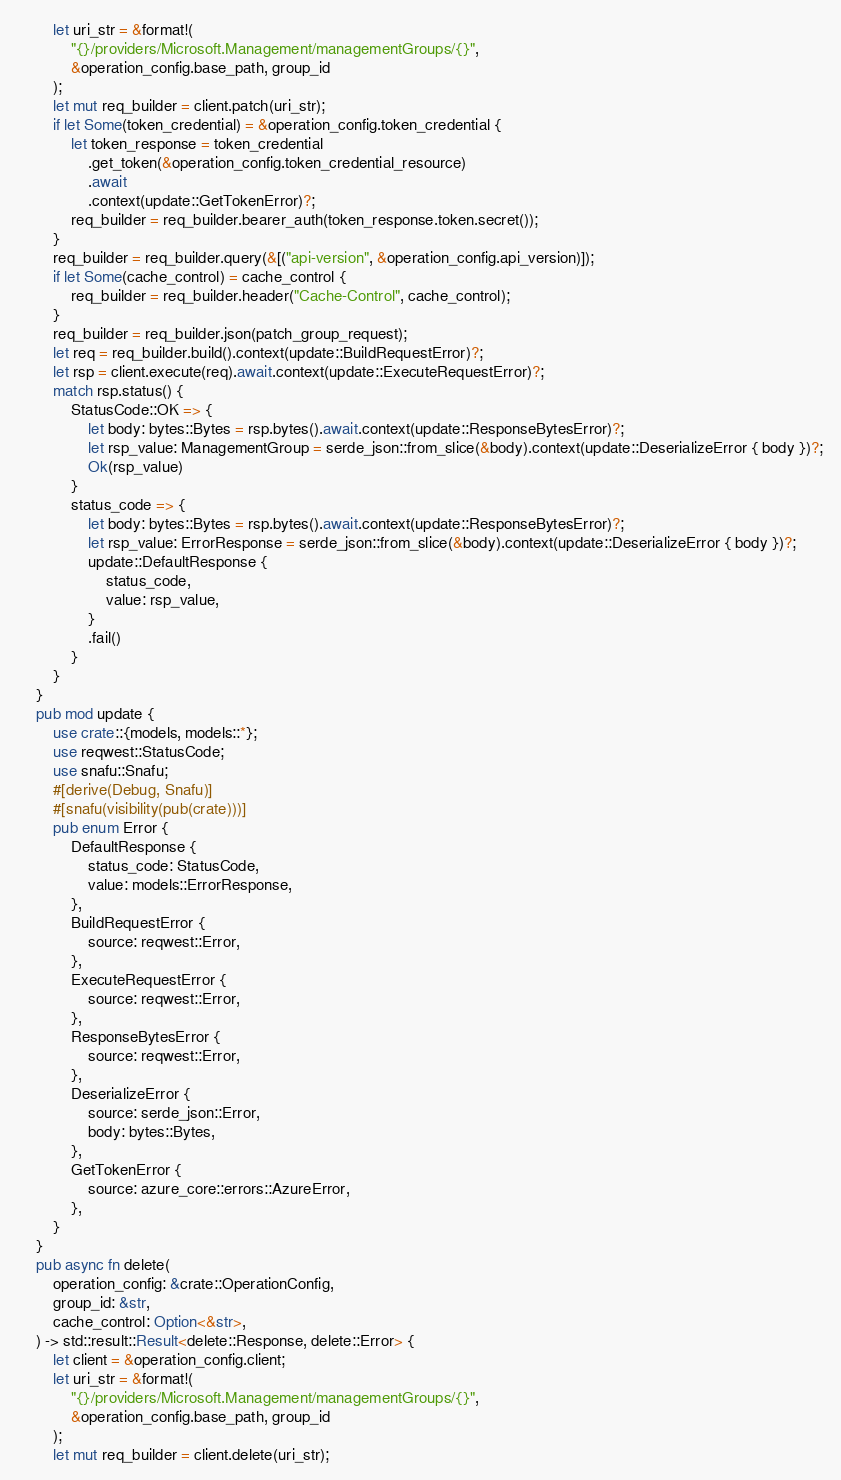Convert code to text. <code><loc_0><loc_0><loc_500><loc_500><_Rust_>        let uri_str = &format!(
            "{}/providers/Microsoft.Management/managementGroups/{}",
            &operation_config.base_path, group_id
        );
        let mut req_builder = client.patch(uri_str);
        if let Some(token_credential) = &operation_config.token_credential {
            let token_response = token_credential
                .get_token(&operation_config.token_credential_resource)
                .await
                .context(update::GetTokenError)?;
            req_builder = req_builder.bearer_auth(token_response.token.secret());
        }
        req_builder = req_builder.query(&[("api-version", &operation_config.api_version)]);
        if let Some(cache_control) = cache_control {
            req_builder = req_builder.header("Cache-Control", cache_control);
        }
        req_builder = req_builder.json(patch_group_request);
        let req = req_builder.build().context(update::BuildRequestError)?;
        let rsp = client.execute(req).await.context(update::ExecuteRequestError)?;
        match rsp.status() {
            StatusCode::OK => {
                let body: bytes::Bytes = rsp.bytes().await.context(update::ResponseBytesError)?;
                let rsp_value: ManagementGroup = serde_json::from_slice(&body).context(update::DeserializeError { body })?;
                Ok(rsp_value)
            }
            status_code => {
                let body: bytes::Bytes = rsp.bytes().await.context(update::ResponseBytesError)?;
                let rsp_value: ErrorResponse = serde_json::from_slice(&body).context(update::DeserializeError { body })?;
                update::DefaultResponse {
                    status_code,
                    value: rsp_value,
                }
                .fail()
            }
        }
    }
    pub mod update {
        use crate::{models, models::*};
        use reqwest::StatusCode;
        use snafu::Snafu;
        #[derive(Debug, Snafu)]
        #[snafu(visibility(pub(crate)))]
        pub enum Error {
            DefaultResponse {
                status_code: StatusCode,
                value: models::ErrorResponse,
            },
            BuildRequestError {
                source: reqwest::Error,
            },
            ExecuteRequestError {
                source: reqwest::Error,
            },
            ResponseBytesError {
                source: reqwest::Error,
            },
            DeserializeError {
                source: serde_json::Error,
                body: bytes::Bytes,
            },
            GetTokenError {
                source: azure_core::errors::AzureError,
            },
        }
    }
    pub async fn delete(
        operation_config: &crate::OperationConfig,
        group_id: &str,
        cache_control: Option<&str>,
    ) -> std::result::Result<delete::Response, delete::Error> {
        let client = &operation_config.client;
        let uri_str = &format!(
            "{}/providers/Microsoft.Management/managementGroups/{}",
            &operation_config.base_path, group_id
        );
        let mut req_builder = client.delete(uri_str);</code> 